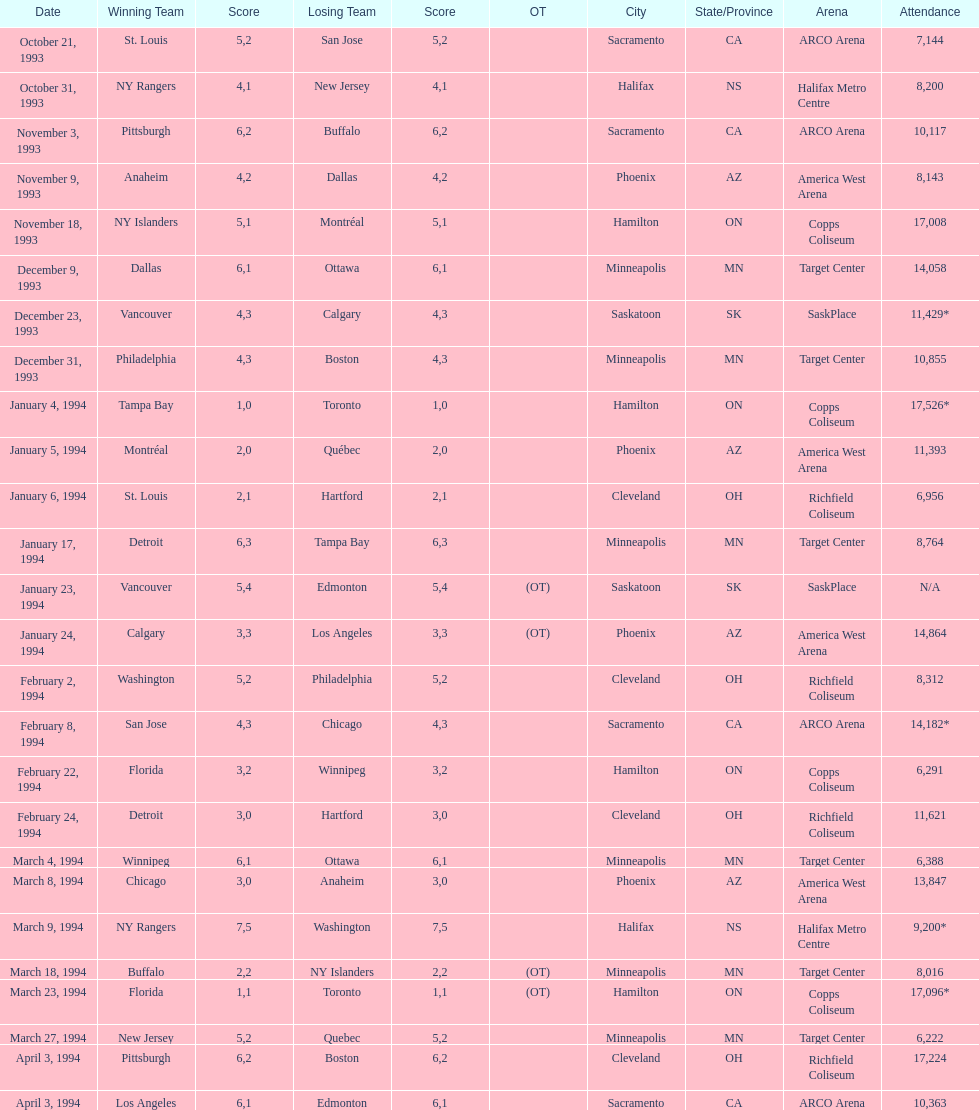Which occasion had greater presence, january 24, 1994, or december 23, 1993? January 4, 1994. 